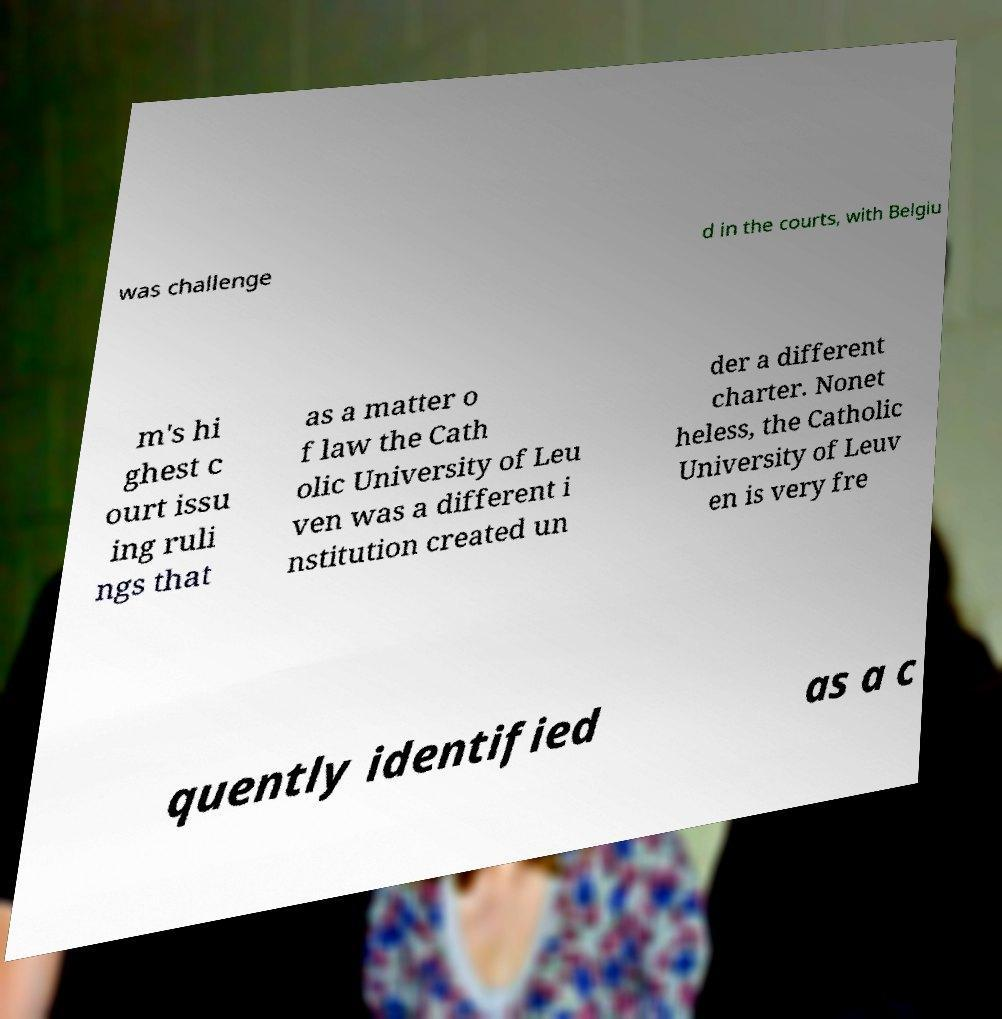Could you extract and type out the text from this image? was challenge d in the courts, with Belgiu m's hi ghest c ourt issu ing ruli ngs that as a matter o f law the Cath olic University of Leu ven was a different i nstitution created un der a different charter. Nonet heless, the Catholic University of Leuv en is very fre quently identified as a c 